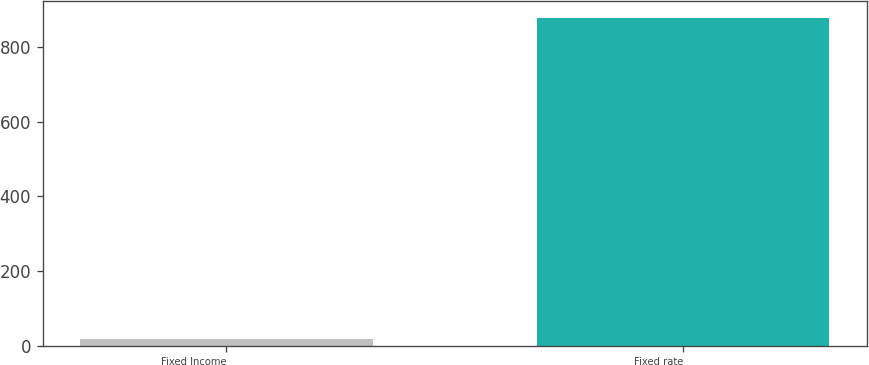Convert chart to OTSL. <chart><loc_0><loc_0><loc_500><loc_500><bar_chart><fcel>Fixed Income<fcel>Fixed rate<nl><fcel>17<fcel>878<nl></chart> 